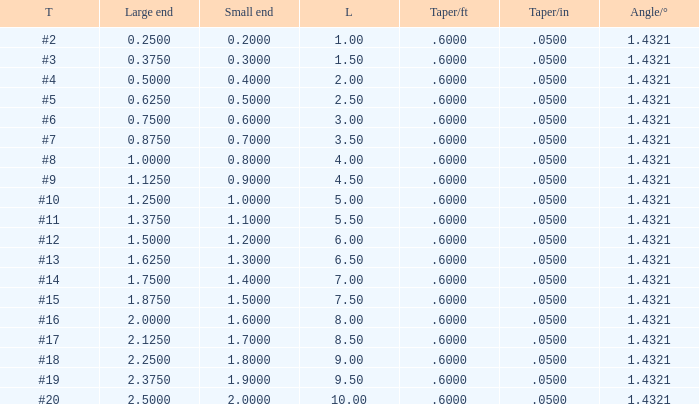Which Angle from center/° has a Taper/ft smaller than 0.6000000000000001? 19.0. 